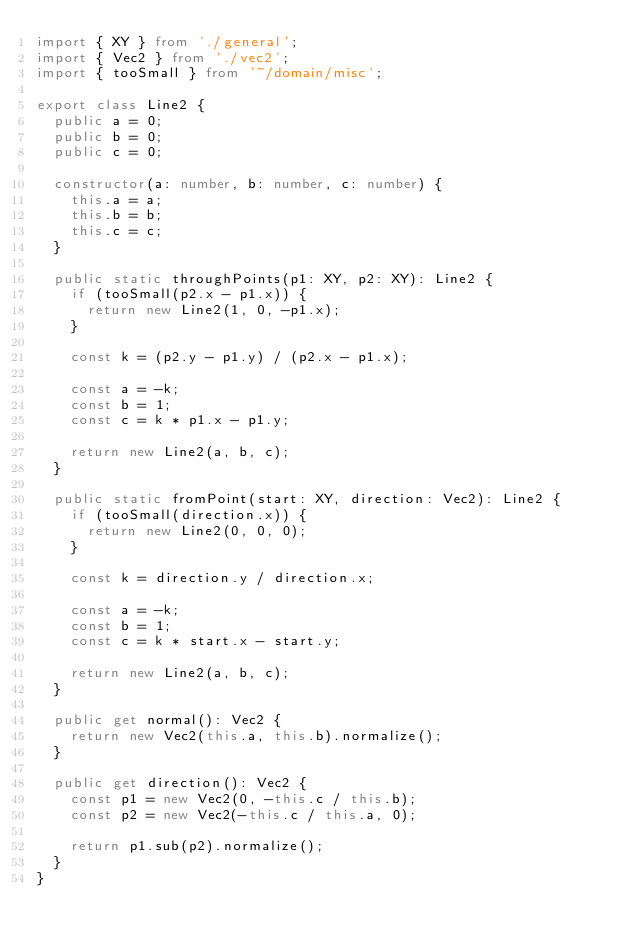Convert code to text. <code><loc_0><loc_0><loc_500><loc_500><_TypeScript_>import { XY } from './general';
import { Vec2 } from './vec2';
import { tooSmall } from '~/domain/misc';

export class Line2 {
  public a = 0;
  public b = 0;
  public c = 0;

  constructor(a: number, b: number, c: number) {
    this.a = a;
    this.b = b;
    this.c = c;
  }

  public static throughPoints(p1: XY, p2: XY): Line2 {
    if (tooSmall(p2.x - p1.x)) {
      return new Line2(1, 0, -p1.x);
    }

    const k = (p2.y - p1.y) / (p2.x - p1.x);

    const a = -k;
    const b = 1;
    const c = k * p1.x - p1.y;

    return new Line2(a, b, c);
  }

  public static fromPoint(start: XY, direction: Vec2): Line2 {
    if (tooSmall(direction.x)) {
      return new Line2(0, 0, 0);
    }

    const k = direction.y / direction.x;

    const a = -k;
    const b = 1;
    const c = k * start.x - start.y;

    return new Line2(a, b, c);
  }

  public get normal(): Vec2 {
    return new Vec2(this.a, this.b).normalize();
  }

  public get direction(): Vec2 {
    const p1 = new Vec2(0, -this.c / this.b);
    const p2 = new Vec2(-this.c / this.a, 0);

    return p1.sub(p2).normalize();
  }
}
</code> 